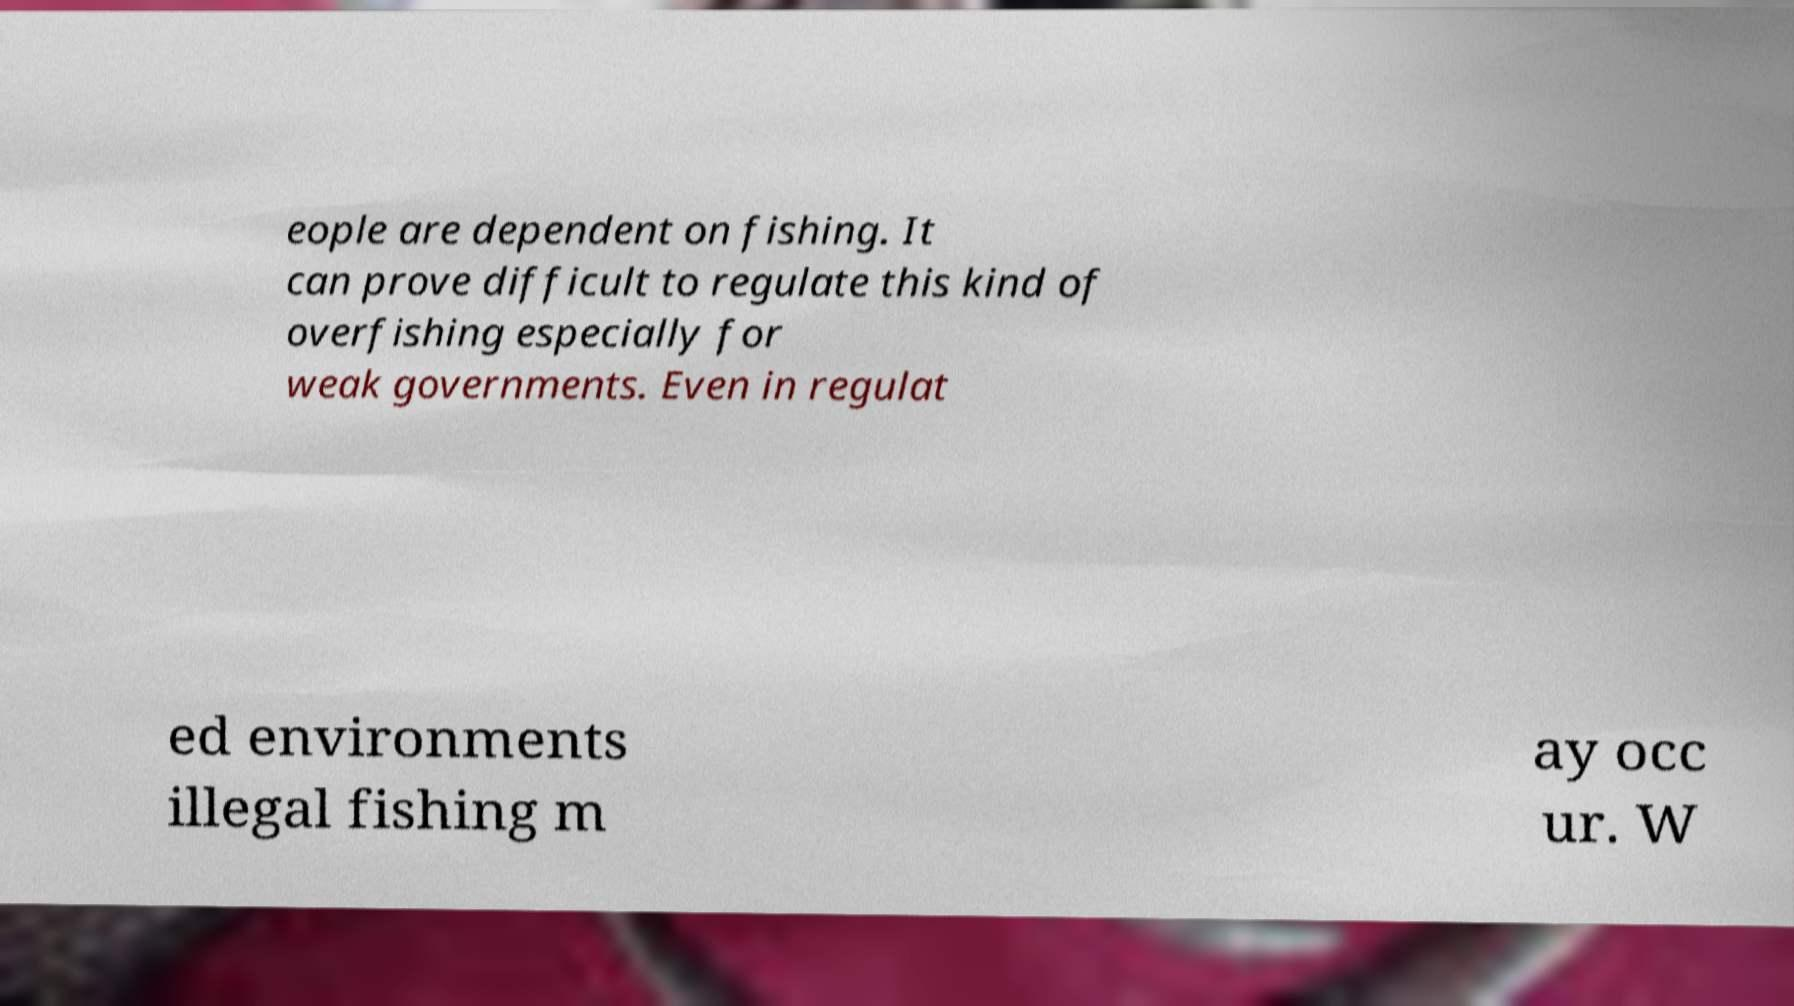I need the written content from this picture converted into text. Can you do that? eople are dependent on fishing. It can prove difficult to regulate this kind of overfishing especially for weak governments. Even in regulat ed environments illegal fishing m ay occ ur. W 